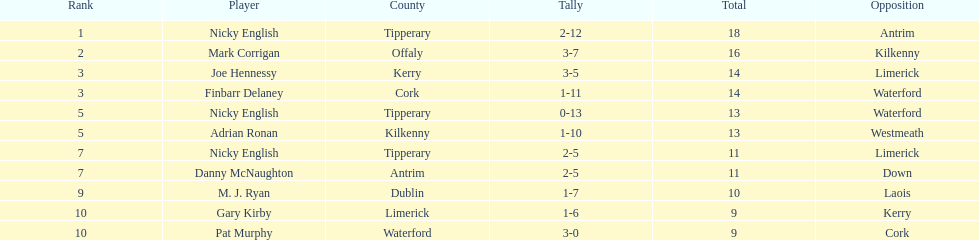Joe hennessy and finbarr delaney both scored how many points? 14. 